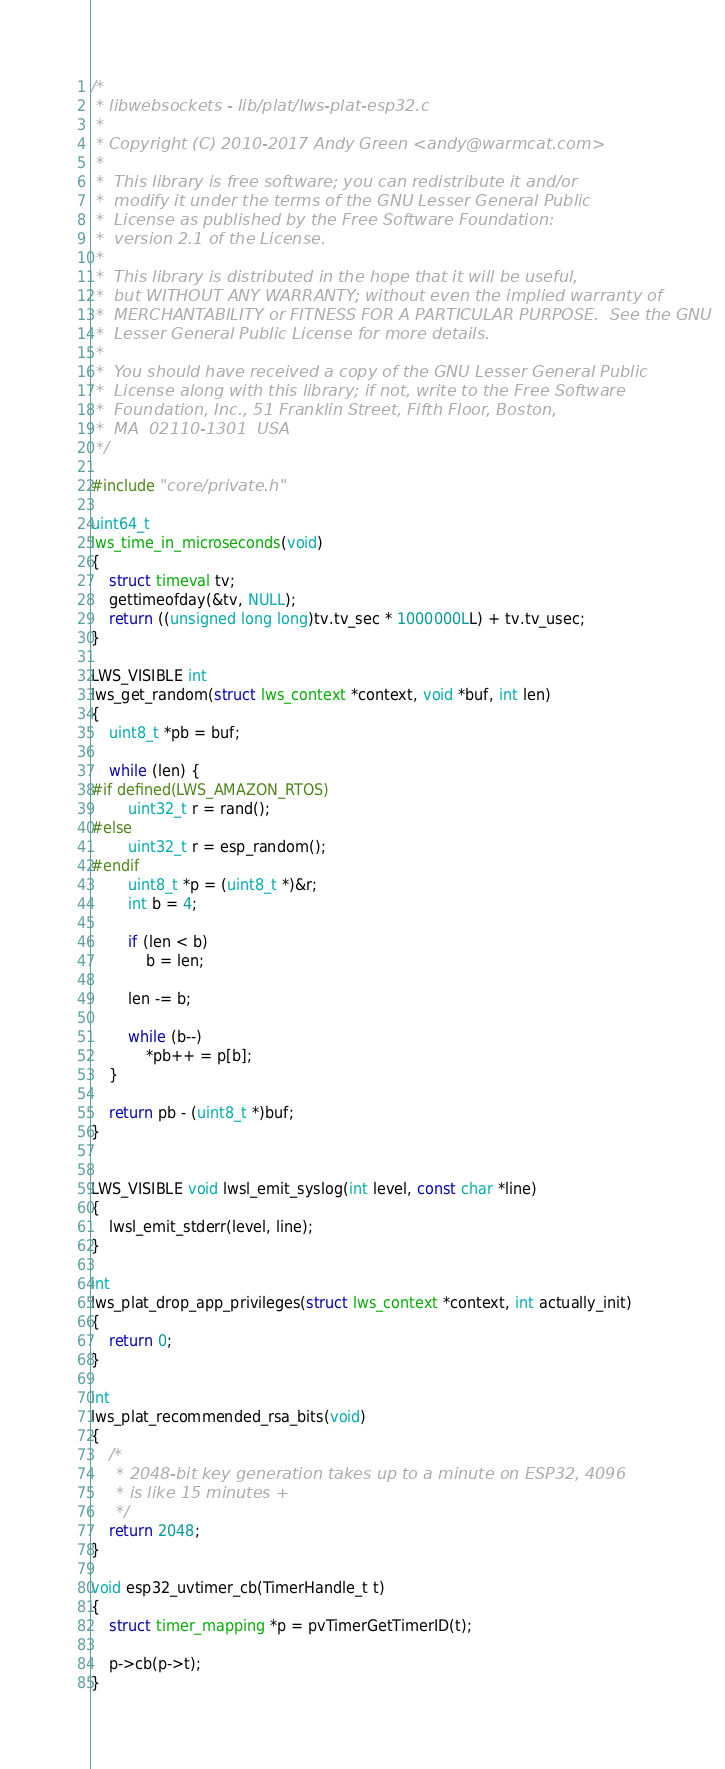<code> <loc_0><loc_0><loc_500><loc_500><_C_>/*
 * libwebsockets - lib/plat/lws-plat-esp32.c
 *
 * Copyright (C) 2010-2017 Andy Green <andy@warmcat.com>
 *
 *  This library is free software; you can redistribute it and/or
 *  modify it under the terms of the GNU Lesser General Public
 *  License as published by the Free Software Foundation:
 *  version 2.1 of the License.
 *
 *  This library is distributed in the hope that it will be useful,
 *  but WITHOUT ANY WARRANTY; without even the implied warranty of
 *  MERCHANTABILITY or FITNESS FOR A PARTICULAR PURPOSE.  See the GNU
 *  Lesser General Public License for more details.
 *
 *  You should have received a copy of the GNU Lesser General Public
 *  License along with this library; if not, write to the Free Software
 *  Foundation, Inc., 51 Franklin Street, Fifth Floor, Boston,
 *  MA  02110-1301  USA
 */

#include "core/private.h"

uint64_t
lws_time_in_microseconds(void)
{
	struct timeval tv;
	gettimeofday(&tv, NULL);
	return ((unsigned long long)tv.tv_sec * 1000000LL) + tv.tv_usec;
}

LWS_VISIBLE int
lws_get_random(struct lws_context *context, void *buf, int len)
{
	uint8_t *pb = buf;

	while (len) {
#if defined(LWS_AMAZON_RTOS)
		uint32_t r = rand();
#else
		uint32_t r = esp_random();
#endif
		uint8_t *p = (uint8_t *)&r;
		int b = 4;

		if (len < b)
			b = len;

		len -= b;

		while (b--)
			*pb++ = p[b];
	}

	return pb - (uint8_t *)buf;
}


LWS_VISIBLE void lwsl_emit_syslog(int level, const char *line)
{
	lwsl_emit_stderr(level, line);
}

int
lws_plat_drop_app_privileges(struct lws_context *context, int actually_init)
{
	return 0;
}

int
lws_plat_recommended_rsa_bits(void)
{
	/*
	 * 2048-bit key generation takes up to a minute on ESP32, 4096
	 * is like 15 minutes +
	 */
	return 2048;
}

void esp32_uvtimer_cb(TimerHandle_t t)
{
	struct timer_mapping *p = pvTimerGetTimerID(t);

	p->cb(p->t);
}

</code> 